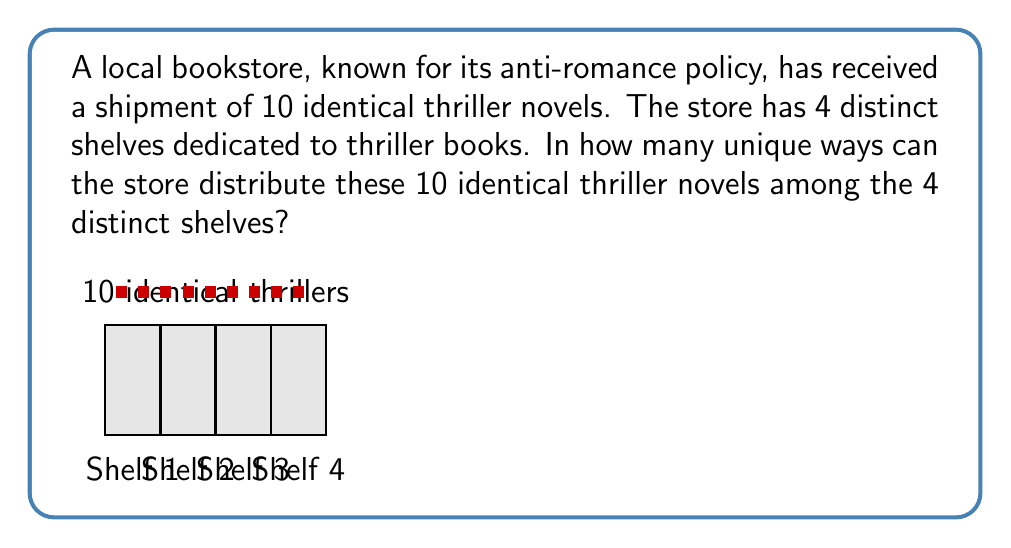Give your solution to this math problem. This problem is a classic example of distributing identical objects into distinct containers. We can solve it using the Stars and Bars method.

1) In the Stars and Bars method, we represent each book as a star and use bars to separate the shelves.

2) We have 10 identical books (stars) and need 3 bars to separate the 4 shelves.

3) The total number of positions we need to consider is:
   10 (books) + 3 (bars) = 13

4) The problem now becomes: In how many ways can we choose 3 positions for the bars out of 13 total positions?

5) This is equivalent to the combination $\binom{13}{3}$ or $\binom{13}{10}$ (since choosing positions for bars is the same as choosing positions for stars).

6) We can calculate this using the formula:

   $$\binom{13}{3} = \frac{13!}{3!(13-3)!} = \frac{13!}{3!10!}$$

7) Expanding this:
   $$\frac{13 \times 12 \times 11 \times 10!}{(3 \times 2 \times 1) \times 10!}$$

8) The 10! cancels out in the numerator and denominator:
   $$\frac{13 \times 12 \times 11}{3 \times 2 \times 1} = \frac{1716}{6} = 286$$

Therefore, there are 286 unique ways to distribute the 10 identical thriller novels among the 4 distinct shelves.
Answer: 286 